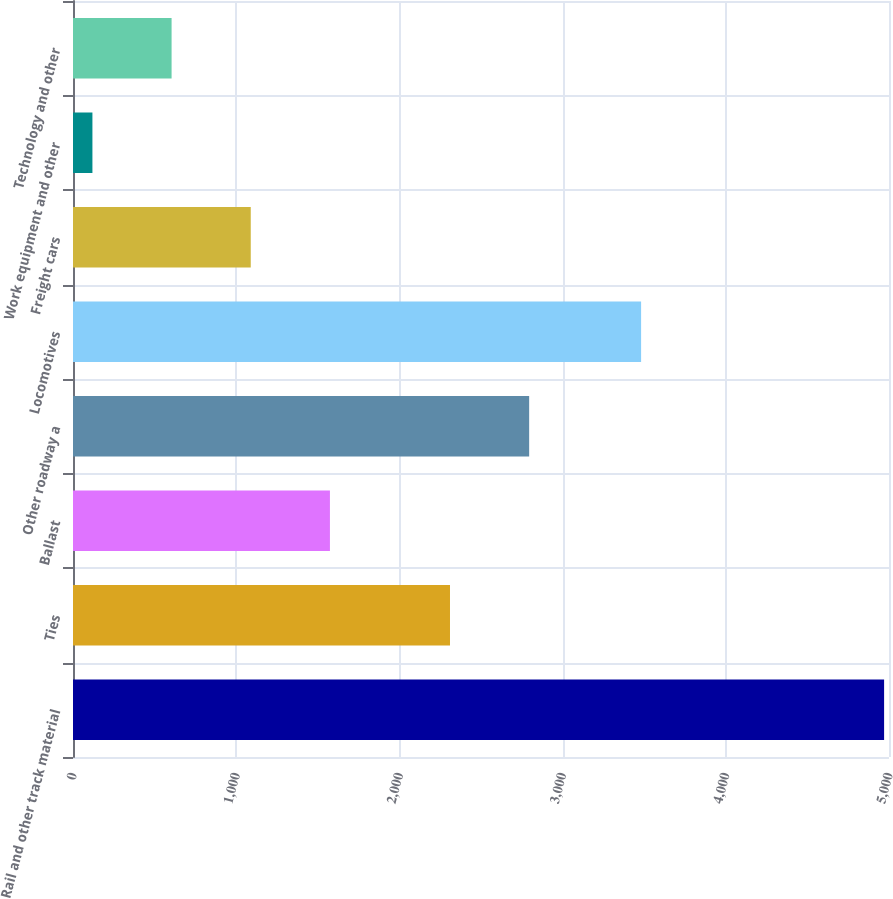Convert chart. <chart><loc_0><loc_0><loc_500><loc_500><bar_chart><fcel>Rail and other track material<fcel>Ties<fcel>Ballast<fcel>Other roadway a<fcel>Locomotives<fcel>Freight cars<fcel>Work equipment and other<fcel>Technology and other<nl><fcel>4970<fcel>2310<fcel>1574.3<fcel>2795.1<fcel>3481<fcel>1089.2<fcel>119<fcel>604.1<nl></chart> 